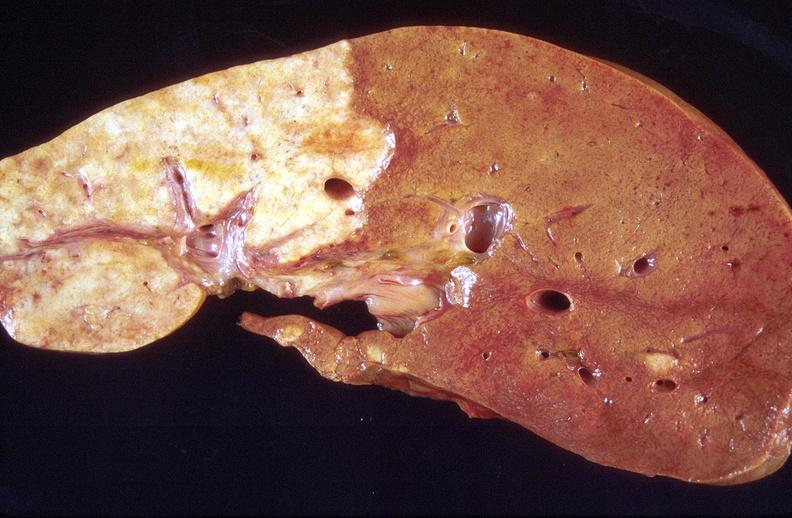s miliary tuberculosis present?
Answer the question using a single word or phrase. No 